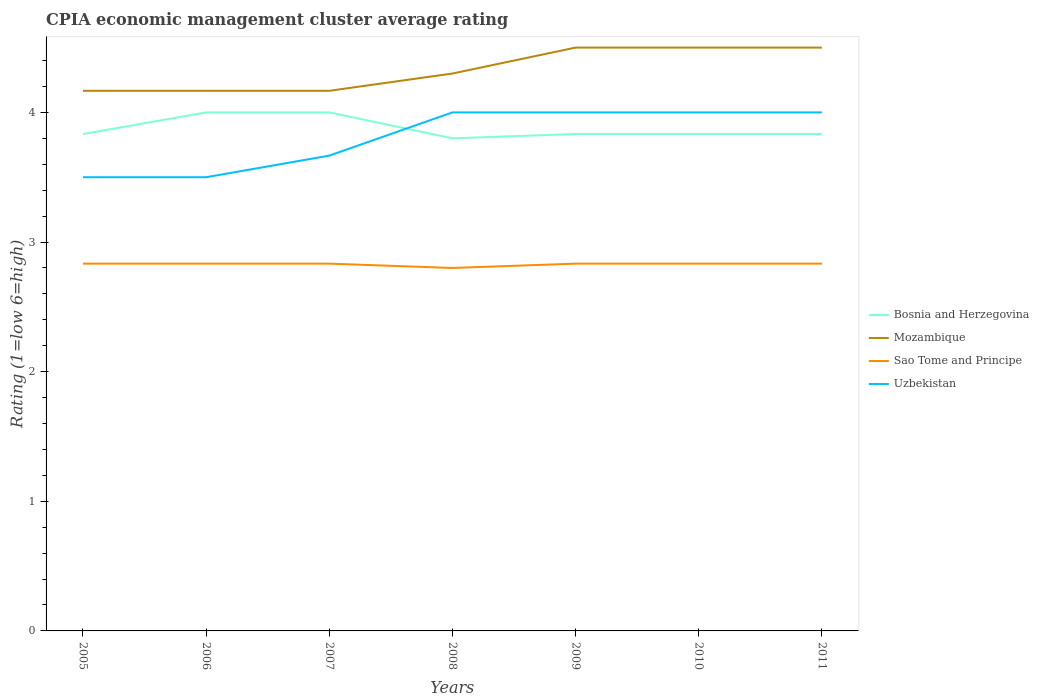How many different coloured lines are there?
Make the answer very short. 4. Is the number of lines equal to the number of legend labels?
Offer a terse response. Yes. In which year was the CPIA rating in Uzbekistan maximum?
Your answer should be compact. 2005. What is the total CPIA rating in Sao Tome and Principe in the graph?
Your answer should be very brief. 0.03. What is the difference between the highest and the second highest CPIA rating in Sao Tome and Principe?
Ensure brevity in your answer.  0.03. How many lines are there?
Ensure brevity in your answer.  4. Are the values on the major ticks of Y-axis written in scientific E-notation?
Give a very brief answer. No. Does the graph contain any zero values?
Your answer should be compact. No. Does the graph contain grids?
Keep it short and to the point. No. How many legend labels are there?
Provide a succinct answer. 4. How are the legend labels stacked?
Offer a very short reply. Vertical. What is the title of the graph?
Ensure brevity in your answer.  CPIA economic management cluster average rating. Does "Senegal" appear as one of the legend labels in the graph?
Provide a short and direct response. No. What is the label or title of the X-axis?
Ensure brevity in your answer.  Years. What is the label or title of the Y-axis?
Your response must be concise. Rating (1=low 6=high). What is the Rating (1=low 6=high) in Bosnia and Herzegovina in 2005?
Provide a succinct answer. 3.83. What is the Rating (1=low 6=high) in Mozambique in 2005?
Your answer should be very brief. 4.17. What is the Rating (1=low 6=high) of Sao Tome and Principe in 2005?
Give a very brief answer. 2.83. What is the Rating (1=low 6=high) in Mozambique in 2006?
Provide a succinct answer. 4.17. What is the Rating (1=low 6=high) in Sao Tome and Principe in 2006?
Make the answer very short. 2.83. What is the Rating (1=low 6=high) in Uzbekistan in 2006?
Your answer should be very brief. 3.5. What is the Rating (1=low 6=high) of Mozambique in 2007?
Keep it short and to the point. 4.17. What is the Rating (1=low 6=high) of Sao Tome and Principe in 2007?
Offer a very short reply. 2.83. What is the Rating (1=low 6=high) of Uzbekistan in 2007?
Keep it short and to the point. 3.67. What is the Rating (1=low 6=high) of Bosnia and Herzegovina in 2008?
Ensure brevity in your answer.  3.8. What is the Rating (1=low 6=high) in Bosnia and Herzegovina in 2009?
Your response must be concise. 3.83. What is the Rating (1=low 6=high) in Sao Tome and Principe in 2009?
Your answer should be very brief. 2.83. What is the Rating (1=low 6=high) in Bosnia and Herzegovina in 2010?
Provide a succinct answer. 3.83. What is the Rating (1=low 6=high) in Mozambique in 2010?
Offer a very short reply. 4.5. What is the Rating (1=low 6=high) of Sao Tome and Principe in 2010?
Your answer should be compact. 2.83. What is the Rating (1=low 6=high) of Uzbekistan in 2010?
Offer a very short reply. 4. What is the Rating (1=low 6=high) in Bosnia and Herzegovina in 2011?
Keep it short and to the point. 3.83. What is the Rating (1=low 6=high) in Sao Tome and Principe in 2011?
Your answer should be very brief. 2.83. What is the Rating (1=low 6=high) of Uzbekistan in 2011?
Your answer should be compact. 4. Across all years, what is the maximum Rating (1=low 6=high) in Sao Tome and Principe?
Give a very brief answer. 2.83. Across all years, what is the maximum Rating (1=low 6=high) in Uzbekistan?
Ensure brevity in your answer.  4. Across all years, what is the minimum Rating (1=low 6=high) in Mozambique?
Make the answer very short. 4.17. Across all years, what is the minimum Rating (1=low 6=high) of Sao Tome and Principe?
Provide a succinct answer. 2.8. What is the total Rating (1=low 6=high) in Bosnia and Herzegovina in the graph?
Your response must be concise. 27.13. What is the total Rating (1=low 6=high) in Mozambique in the graph?
Your response must be concise. 30.3. What is the total Rating (1=low 6=high) in Sao Tome and Principe in the graph?
Make the answer very short. 19.8. What is the total Rating (1=low 6=high) of Uzbekistan in the graph?
Keep it short and to the point. 26.67. What is the difference between the Rating (1=low 6=high) in Bosnia and Herzegovina in 2005 and that in 2006?
Your response must be concise. -0.17. What is the difference between the Rating (1=low 6=high) in Sao Tome and Principe in 2005 and that in 2006?
Your response must be concise. 0. What is the difference between the Rating (1=low 6=high) in Bosnia and Herzegovina in 2005 and that in 2007?
Provide a succinct answer. -0.17. What is the difference between the Rating (1=low 6=high) of Mozambique in 2005 and that in 2007?
Your answer should be compact. 0. What is the difference between the Rating (1=low 6=high) of Sao Tome and Principe in 2005 and that in 2007?
Provide a succinct answer. 0. What is the difference between the Rating (1=low 6=high) in Uzbekistan in 2005 and that in 2007?
Your response must be concise. -0.17. What is the difference between the Rating (1=low 6=high) of Bosnia and Herzegovina in 2005 and that in 2008?
Keep it short and to the point. 0.03. What is the difference between the Rating (1=low 6=high) in Mozambique in 2005 and that in 2008?
Keep it short and to the point. -0.13. What is the difference between the Rating (1=low 6=high) in Uzbekistan in 2005 and that in 2008?
Offer a terse response. -0.5. What is the difference between the Rating (1=low 6=high) in Sao Tome and Principe in 2005 and that in 2009?
Your response must be concise. 0. What is the difference between the Rating (1=low 6=high) of Sao Tome and Principe in 2005 and that in 2010?
Your answer should be compact. 0. What is the difference between the Rating (1=low 6=high) in Uzbekistan in 2005 and that in 2010?
Give a very brief answer. -0.5. What is the difference between the Rating (1=low 6=high) in Bosnia and Herzegovina in 2005 and that in 2011?
Ensure brevity in your answer.  0. What is the difference between the Rating (1=low 6=high) in Mozambique in 2005 and that in 2011?
Offer a terse response. -0.33. What is the difference between the Rating (1=low 6=high) in Uzbekistan in 2005 and that in 2011?
Give a very brief answer. -0.5. What is the difference between the Rating (1=low 6=high) in Bosnia and Herzegovina in 2006 and that in 2007?
Provide a short and direct response. 0. What is the difference between the Rating (1=low 6=high) of Sao Tome and Principe in 2006 and that in 2007?
Your response must be concise. 0. What is the difference between the Rating (1=low 6=high) of Bosnia and Herzegovina in 2006 and that in 2008?
Provide a succinct answer. 0.2. What is the difference between the Rating (1=low 6=high) in Mozambique in 2006 and that in 2008?
Ensure brevity in your answer.  -0.13. What is the difference between the Rating (1=low 6=high) in Sao Tome and Principe in 2006 and that in 2008?
Your response must be concise. 0.03. What is the difference between the Rating (1=low 6=high) in Sao Tome and Principe in 2006 and that in 2009?
Your answer should be compact. 0. What is the difference between the Rating (1=low 6=high) of Bosnia and Herzegovina in 2006 and that in 2010?
Keep it short and to the point. 0.17. What is the difference between the Rating (1=low 6=high) in Mozambique in 2006 and that in 2010?
Provide a succinct answer. -0.33. What is the difference between the Rating (1=low 6=high) in Sao Tome and Principe in 2006 and that in 2010?
Make the answer very short. 0. What is the difference between the Rating (1=low 6=high) in Bosnia and Herzegovina in 2006 and that in 2011?
Offer a terse response. 0.17. What is the difference between the Rating (1=low 6=high) of Mozambique in 2007 and that in 2008?
Your answer should be compact. -0.13. What is the difference between the Rating (1=low 6=high) of Sao Tome and Principe in 2007 and that in 2008?
Give a very brief answer. 0.03. What is the difference between the Rating (1=low 6=high) of Uzbekistan in 2007 and that in 2009?
Keep it short and to the point. -0.33. What is the difference between the Rating (1=low 6=high) in Bosnia and Herzegovina in 2007 and that in 2010?
Offer a very short reply. 0.17. What is the difference between the Rating (1=low 6=high) of Mozambique in 2007 and that in 2010?
Offer a terse response. -0.33. What is the difference between the Rating (1=low 6=high) in Sao Tome and Principe in 2007 and that in 2010?
Offer a very short reply. 0. What is the difference between the Rating (1=low 6=high) in Bosnia and Herzegovina in 2007 and that in 2011?
Your answer should be compact. 0.17. What is the difference between the Rating (1=low 6=high) in Sao Tome and Principe in 2007 and that in 2011?
Offer a very short reply. 0. What is the difference between the Rating (1=low 6=high) of Bosnia and Herzegovina in 2008 and that in 2009?
Offer a very short reply. -0.03. What is the difference between the Rating (1=low 6=high) in Mozambique in 2008 and that in 2009?
Offer a very short reply. -0.2. What is the difference between the Rating (1=low 6=high) in Sao Tome and Principe in 2008 and that in 2009?
Your answer should be very brief. -0.03. What is the difference between the Rating (1=low 6=high) in Bosnia and Herzegovina in 2008 and that in 2010?
Keep it short and to the point. -0.03. What is the difference between the Rating (1=low 6=high) in Sao Tome and Principe in 2008 and that in 2010?
Give a very brief answer. -0.03. What is the difference between the Rating (1=low 6=high) of Bosnia and Herzegovina in 2008 and that in 2011?
Ensure brevity in your answer.  -0.03. What is the difference between the Rating (1=low 6=high) in Mozambique in 2008 and that in 2011?
Your response must be concise. -0.2. What is the difference between the Rating (1=low 6=high) of Sao Tome and Principe in 2008 and that in 2011?
Keep it short and to the point. -0.03. What is the difference between the Rating (1=low 6=high) of Bosnia and Herzegovina in 2009 and that in 2011?
Your answer should be very brief. 0. What is the difference between the Rating (1=low 6=high) of Mozambique in 2009 and that in 2011?
Give a very brief answer. 0. What is the difference between the Rating (1=low 6=high) in Uzbekistan in 2009 and that in 2011?
Provide a succinct answer. 0. What is the difference between the Rating (1=low 6=high) in Mozambique in 2010 and that in 2011?
Provide a succinct answer. 0. What is the difference between the Rating (1=low 6=high) of Sao Tome and Principe in 2010 and that in 2011?
Offer a very short reply. 0. What is the difference between the Rating (1=low 6=high) in Uzbekistan in 2010 and that in 2011?
Provide a succinct answer. 0. What is the difference between the Rating (1=low 6=high) of Bosnia and Herzegovina in 2005 and the Rating (1=low 6=high) of Mozambique in 2006?
Provide a succinct answer. -0.33. What is the difference between the Rating (1=low 6=high) in Bosnia and Herzegovina in 2005 and the Rating (1=low 6=high) in Uzbekistan in 2006?
Offer a very short reply. 0.33. What is the difference between the Rating (1=low 6=high) in Mozambique in 2005 and the Rating (1=low 6=high) in Uzbekistan in 2006?
Your answer should be very brief. 0.67. What is the difference between the Rating (1=low 6=high) of Mozambique in 2005 and the Rating (1=low 6=high) of Uzbekistan in 2007?
Offer a very short reply. 0.5. What is the difference between the Rating (1=low 6=high) of Bosnia and Herzegovina in 2005 and the Rating (1=low 6=high) of Mozambique in 2008?
Provide a short and direct response. -0.47. What is the difference between the Rating (1=low 6=high) of Bosnia and Herzegovina in 2005 and the Rating (1=low 6=high) of Sao Tome and Principe in 2008?
Provide a succinct answer. 1.03. What is the difference between the Rating (1=low 6=high) in Mozambique in 2005 and the Rating (1=low 6=high) in Sao Tome and Principe in 2008?
Offer a terse response. 1.37. What is the difference between the Rating (1=low 6=high) in Sao Tome and Principe in 2005 and the Rating (1=low 6=high) in Uzbekistan in 2008?
Offer a terse response. -1.17. What is the difference between the Rating (1=low 6=high) in Mozambique in 2005 and the Rating (1=low 6=high) in Sao Tome and Principe in 2009?
Ensure brevity in your answer.  1.33. What is the difference between the Rating (1=low 6=high) of Sao Tome and Principe in 2005 and the Rating (1=low 6=high) of Uzbekistan in 2009?
Give a very brief answer. -1.17. What is the difference between the Rating (1=low 6=high) in Bosnia and Herzegovina in 2005 and the Rating (1=low 6=high) in Sao Tome and Principe in 2010?
Give a very brief answer. 1. What is the difference between the Rating (1=low 6=high) of Sao Tome and Principe in 2005 and the Rating (1=low 6=high) of Uzbekistan in 2010?
Offer a very short reply. -1.17. What is the difference between the Rating (1=low 6=high) in Bosnia and Herzegovina in 2005 and the Rating (1=low 6=high) in Mozambique in 2011?
Your answer should be compact. -0.67. What is the difference between the Rating (1=low 6=high) in Bosnia and Herzegovina in 2005 and the Rating (1=low 6=high) in Sao Tome and Principe in 2011?
Your response must be concise. 1. What is the difference between the Rating (1=low 6=high) in Mozambique in 2005 and the Rating (1=low 6=high) in Uzbekistan in 2011?
Ensure brevity in your answer.  0.17. What is the difference between the Rating (1=low 6=high) in Sao Tome and Principe in 2005 and the Rating (1=low 6=high) in Uzbekistan in 2011?
Provide a succinct answer. -1.17. What is the difference between the Rating (1=low 6=high) of Bosnia and Herzegovina in 2006 and the Rating (1=low 6=high) of Sao Tome and Principe in 2007?
Your answer should be very brief. 1.17. What is the difference between the Rating (1=low 6=high) in Bosnia and Herzegovina in 2006 and the Rating (1=low 6=high) in Uzbekistan in 2007?
Provide a short and direct response. 0.33. What is the difference between the Rating (1=low 6=high) of Mozambique in 2006 and the Rating (1=low 6=high) of Sao Tome and Principe in 2007?
Offer a terse response. 1.33. What is the difference between the Rating (1=low 6=high) of Mozambique in 2006 and the Rating (1=low 6=high) of Uzbekistan in 2007?
Your response must be concise. 0.5. What is the difference between the Rating (1=low 6=high) in Sao Tome and Principe in 2006 and the Rating (1=low 6=high) in Uzbekistan in 2007?
Make the answer very short. -0.83. What is the difference between the Rating (1=low 6=high) of Bosnia and Herzegovina in 2006 and the Rating (1=low 6=high) of Mozambique in 2008?
Offer a very short reply. -0.3. What is the difference between the Rating (1=low 6=high) of Mozambique in 2006 and the Rating (1=low 6=high) of Sao Tome and Principe in 2008?
Offer a very short reply. 1.37. What is the difference between the Rating (1=low 6=high) in Mozambique in 2006 and the Rating (1=low 6=high) in Uzbekistan in 2008?
Make the answer very short. 0.17. What is the difference between the Rating (1=low 6=high) in Sao Tome and Principe in 2006 and the Rating (1=low 6=high) in Uzbekistan in 2008?
Give a very brief answer. -1.17. What is the difference between the Rating (1=low 6=high) of Bosnia and Herzegovina in 2006 and the Rating (1=low 6=high) of Sao Tome and Principe in 2009?
Your answer should be compact. 1.17. What is the difference between the Rating (1=low 6=high) in Mozambique in 2006 and the Rating (1=low 6=high) in Sao Tome and Principe in 2009?
Keep it short and to the point. 1.33. What is the difference between the Rating (1=low 6=high) of Sao Tome and Principe in 2006 and the Rating (1=low 6=high) of Uzbekistan in 2009?
Your answer should be compact. -1.17. What is the difference between the Rating (1=low 6=high) of Bosnia and Herzegovina in 2006 and the Rating (1=low 6=high) of Sao Tome and Principe in 2010?
Provide a succinct answer. 1.17. What is the difference between the Rating (1=low 6=high) of Mozambique in 2006 and the Rating (1=low 6=high) of Sao Tome and Principe in 2010?
Offer a very short reply. 1.33. What is the difference between the Rating (1=low 6=high) in Sao Tome and Principe in 2006 and the Rating (1=low 6=high) in Uzbekistan in 2010?
Give a very brief answer. -1.17. What is the difference between the Rating (1=low 6=high) in Bosnia and Herzegovina in 2006 and the Rating (1=low 6=high) in Sao Tome and Principe in 2011?
Offer a very short reply. 1.17. What is the difference between the Rating (1=low 6=high) in Sao Tome and Principe in 2006 and the Rating (1=low 6=high) in Uzbekistan in 2011?
Provide a short and direct response. -1.17. What is the difference between the Rating (1=low 6=high) in Bosnia and Herzegovina in 2007 and the Rating (1=low 6=high) in Mozambique in 2008?
Keep it short and to the point. -0.3. What is the difference between the Rating (1=low 6=high) in Mozambique in 2007 and the Rating (1=low 6=high) in Sao Tome and Principe in 2008?
Provide a succinct answer. 1.37. What is the difference between the Rating (1=low 6=high) of Sao Tome and Principe in 2007 and the Rating (1=low 6=high) of Uzbekistan in 2008?
Your answer should be very brief. -1.17. What is the difference between the Rating (1=low 6=high) in Mozambique in 2007 and the Rating (1=low 6=high) in Sao Tome and Principe in 2009?
Offer a very short reply. 1.33. What is the difference between the Rating (1=low 6=high) in Mozambique in 2007 and the Rating (1=low 6=high) in Uzbekistan in 2009?
Provide a succinct answer. 0.17. What is the difference between the Rating (1=low 6=high) in Sao Tome and Principe in 2007 and the Rating (1=low 6=high) in Uzbekistan in 2009?
Your answer should be compact. -1.17. What is the difference between the Rating (1=low 6=high) of Bosnia and Herzegovina in 2007 and the Rating (1=low 6=high) of Uzbekistan in 2010?
Keep it short and to the point. 0. What is the difference between the Rating (1=low 6=high) of Sao Tome and Principe in 2007 and the Rating (1=low 6=high) of Uzbekistan in 2010?
Make the answer very short. -1.17. What is the difference between the Rating (1=low 6=high) of Bosnia and Herzegovina in 2007 and the Rating (1=low 6=high) of Uzbekistan in 2011?
Keep it short and to the point. 0. What is the difference between the Rating (1=low 6=high) in Mozambique in 2007 and the Rating (1=low 6=high) in Sao Tome and Principe in 2011?
Keep it short and to the point. 1.33. What is the difference between the Rating (1=low 6=high) in Mozambique in 2007 and the Rating (1=low 6=high) in Uzbekistan in 2011?
Your response must be concise. 0.17. What is the difference between the Rating (1=low 6=high) of Sao Tome and Principe in 2007 and the Rating (1=low 6=high) of Uzbekistan in 2011?
Make the answer very short. -1.17. What is the difference between the Rating (1=low 6=high) in Bosnia and Herzegovina in 2008 and the Rating (1=low 6=high) in Mozambique in 2009?
Make the answer very short. -0.7. What is the difference between the Rating (1=low 6=high) of Bosnia and Herzegovina in 2008 and the Rating (1=low 6=high) of Sao Tome and Principe in 2009?
Your answer should be compact. 0.97. What is the difference between the Rating (1=low 6=high) in Mozambique in 2008 and the Rating (1=low 6=high) in Sao Tome and Principe in 2009?
Your answer should be very brief. 1.47. What is the difference between the Rating (1=low 6=high) of Sao Tome and Principe in 2008 and the Rating (1=low 6=high) of Uzbekistan in 2009?
Make the answer very short. -1.2. What is the difference between the Rating (1=low 6=high) in Bosnia and Herzegovina in 2008 and the Rating (1=low 6=high) in Mozambique in 2010?
Your answer should be very brief. -0.7. What is the difference between the Rating (1=low 6=high) of Bosnia and Herzegovina in 2008 and the Rating (1=low 6=high) of Sao Tome and Principe in 2010?
Make the answer very short. 0.97. What is the difference between the Rating (1=low 6=high) in Bosnia and Herzegovina in 2008 and the Rating (1=low 6=high) in Uzbekistan in 2010?
Ensure brevity in your answer.  -0.2. What is the difference between the Rating (1=low 6=high) of Mozambique in 2008 and the Rating (1=low 6=high) of Sao Tome and Principe in 2010?
Offer a very short reply. 1.47. What is the difference between the Rating (1=low 6=high) in Sao Tome and Principe in 2008 and the Rating (1=low 6=high) in Uzbekistan in 2010?
Your answer should be very brief. -1.2. What is the difference between the Rating (1=low 6=high) in Bosnia and Herzegovina in 2008 and the Rating (1=low 6=high) in Mozambique in 2011?
Make the answer very short. -0.7. What is the difference between the Rating (1=low 6=high) of Bosnia and Herzegovina in 2008 and the Rating (1=low 6=high) of Sao Tome and Principe in 2011?
Provide a short and direct response. 0.97. What is the difference between the Rating (1=low 6=high) in Bosnia and Herzegovina in 2008 and the Rating (1=low 6=high) in Uzbekistan in 2011?
Offer a terse response. -0.2. What is the difference between the Rating (1=low 6=high) of Mozambique in 2008 and the Rating (1=low 6=high) of Sao Tome and Principe in 2011?
Give a very brief answer. 1.47. What is the difference between the Rating (1=low 6=high) of Mozambique in 2008 and the Rating (1=low 6=high) of Uzbekistan in 2011?
Ensure brevity in your answer.  0.3. What is the difference between the Rating (1=low 6=high) of Bosnia and Herzegovina in 2009 and the Rating (1=low 6=high) of Mozambique in 2010?
Your response must be concise. -0.67. What is the difference between the Rating (1=low 6=high) of Bosnia and Herzegovina in 2009 and the Rating (1=low 6=high) of Uzbekistan in 2010?
Offer a terse response. -0.17. What is the difference between the Rating (1=low 6=high) in Mozambique in 2009 and the Rating (1=low 6=high) in Uzbekistan in 2010?
Give a very brief answer. 0.5. What is the difference between the Rating (1=low 6=high) in Sao Tome and Principe in 2009 and the Rating (1=low 6=high) in Uzbekistan in 2010?
Keep it short and to the point. -1.17. What is the difference between the Rating (1=low 6=high) in Bosnia and Herzegovina in 2009 and the Rating (1=low 6=high) in Mozambique in 2011?
Offer a very short reply. -0.67. What is the difference between the Rating (1=low 6=high) of Bosnia and Herzegovina in 2009 and the Rating (1=low 6=high) of Sao Tome and Principe in 2011?
Your answer should be very brief. 1. What is the difference between the Rating (1=low 6=high) in Mozambique in 2009 and the Rating (1=low 6=high) in Uzbekistan in 2011?
Offer a terse response. 0.5. What is the difference between the Rating (1=low 6=high) of Sao Tome and Principe in 2009 and the Rating (1=low 6=high) of Uzbekistan in 2011?
Keep it short and to the point. -1.17. What is the difference between the Rating (1=low 6=high) of Mozambique in 2010 and the Rating (1=low 6=high) of Uzbekistan in 2011?
Your answer should be very brief. 0.5. What is the difference between the Rating (1=low 6=high) of Sao Tome and Principe in 2010 and the Rating (1=low 6=high) of Uzbekistan in 2011?
Provide a short and direct response. -1.17. What is the average Rating (1=low 6=high) of Bosnia and Herzegovina per year?
Offer a very short reply. 3.88. What is the average Rating (1=low 6=high) of Mozambique per year?
Provide a short and direct response. 4.33. What is the average Rating (1=low 6=high) of Sao Tome and Principe per year?
Make the answer very short. 2.83. What is the average Rating (1=low 6=high) in Uzbekistan per year?
Keep it short and to the point. 3.81. In the year 2005, what is the difference between the Rating (1=low 6=high) of Bosnia and Herzegovina and Rating (1=low 6=high) of Sao Tome and Principe?
Your answer should be compact. 1. In the year 2005, what is the difference between the Rating (1=low 6=high) of Bosnia and Herzegovina and Rating (1=low 6=high) of Uzbekistan?
Offer a very short reply. 0.33. In the year 2005, what is the difference between the Rating (1=low 6=high) of Mozambique and Rating (1=low 6=high) of Uzbekistan?
Offer a very short reply. 0.67. In the year 2006, what is the difference between the Rating (1=low 6=high) in Bosnia and Herzegovina and Rating (1=low 6=high) in Mozambique?
Your answer should be compact. -0.17. In the year 2006, what is the difference between the Rating (1=low 6=high) in Bosnia and Herzegovina and Rating (1=low 6=high) in Uzbekistan?
Ensure brevity in your answer.  0.5. In the year 2006, what is the difference between the Rating (1=low 6=high) of Mozambique and Rating (1=low 6=high) of Uzbekistan?
Ensure brevity in your answer.  0.67. In the year 2006, what is the difference between the Rating (1=low 6=high) of Sao Tome and Principe and Rating (1=low 6=high) of Uzbekistan?
Your answer should be very brief. -0.67. In the year 2007, what is the difference between the Rating (1=low 6=high) in Bosnia and Herzegovina and Rating (1=low 6=high) in Mozambique?
Provide a short and direct response. -0.17. In the year 2007, what is the difference between the Rating (1=low 6=high) of Bosnia and Herzegovina and Rating (1=low 6=high) of Uzbekistan?
Provide a succinct answer. 0.33. In the year 2007, what is the difference between the Rating (1=low 6=high) of Mozambique and Rating (1=low 6=high) of Sao Tome and Principe?
Offer a very short reply. 1.33. In the year 2008, what is the difference between the Rating (1=low 6=high) in Bosnia and Herzegovina and Rating (1=low 6=high) in Mozambique?
Offer a very short reply. -0.5. In the year 2008, what is the difference between the Rating (1=low 6=high) of Bosnia and Herzegovina and Rating (1=low 6=high) of Uzbekistan?
Give a very brief answer. -0.2. In the year 2009, what is the difference between the Rating (1=low 6=high) in Bosnia and Herzegovina and Rating (1=low 6=high) in Mozambique?
Offer a very short reply. -0.67. In the year 2009, what is the difference between the Rating (1=low 6=high) in Bosnia and Herzegovina and Rating (1=low 6=high) in Sao Tome and Principe?
Your answer should be very brief. 1. In the year 2009, what is the difference between the Rating (1=low 6=high) of Bosnia and Herzegovina and Rating (1=low 6=high) of Uzbekistan?
Provide a succinct answer. -0.17. In the year 2009, what is the difference between the Rating (1=low 6=high) in Mozambique and Rating (1=low 6=high) in Uzbekistan?
Keep it short and to the point. 0.5. In the year 2009, what is the difference between the Rating (1=low 6=high) in Sao Tome and Principe and Rating (1=low 6=high) in Uzbekistan?
Your response must be concise. -1.17. In the year 2010, what is the difference between the Rating (1=low 6=high) of Bosnia and Herzegovina and Rating (1=low 6=high) of Mozambique?
Your answer should be compact. -0.67. In the year 2010, what is the difference between the Rating (1=low 6=high) in Mozambique and Rating (1=low 6=high) in Sao Tome and Principe?
Your answer should be very brief. 1.67. In the year 2010, what is the difference between the Rating (1=low 6=high) in Mozambique and Rating (1=low 6=high) in Uzbekistan?
Ensure brevity in your answer.  0.5. In the year 2010, what is the difference between the Rating (1=low 6=high) in Sao Tome and Principe and Rating (1=low 6=high) in Uzbekistan?
Make the answer very short. -1.17. In the year 2011, what is the difference between the Rating (1=low 6=high) of Bosnia and Herzegovina and Rating (1=low 6=high) of Mozambique?
Your answer should be compact. -0.67. In the year 2011, what is the difference between the Rating (1=low 6=high) in Bosnia and Herzegovina and Rating (1=low 6=high) in Sao Tome and Principe?
Offer a very short reply. 1. In the year 2011, what is the difference between the Rating (1=low 6=high) in Sao Tome and Principe and Rating (1=low 6=high) in Uzbekistan?
Make the answer very short. -1.17. What is the ratio of the Rating (1=low 6=high) of Bosnia and Herzegovina in 2005 to that in 2006?
Provide a succinct answer. 0.96. What is the ratio of the Rating (1=low 6=high) in Mozambique in 2005 to that in 2006?
Make the answer very short. 1. What is the ratio of the Rating (1=low 6=high) in Sao Tome and Principe in 2005 to that in 2006?
Offer a very short reply. 1. What is the ratio of the Rating (1=low 6=high) in Uzbekistan in 2005 to that in 2006?
Ensure brevity in your answer.  1. What is the ratio of the Rating (1=low 6=high) of Mozambique in 2005 to that in 2007?
Provide a succinct answer. 1. What is the ratio of the Rating (1=low 6=high) of Uzbekistan in 2005 to that in 2007?
Give a very brief answer. 0.95. What is the ratio of the Rating (1=low 6=high) of Bosnia and Herzegovina in 2005 to that in 2008?
Provide a short and direct response. 1.01. What is the ratio of the Rating (1=low 6=high) of Mozambique in 2005 to that in 2008?
Keep it short and to the point. 0.97. What is the ratio of the Rating (1=low 6=high) in Sao Tome and Principe in 2005 to that in 2008?
Make the answer very short. 1.01. What is the ratio of the Rating (1=low 6=high) of Bosnia and Herzegovina in 2005 to that in 2009?
Keep it short and to the point. 1. What is the ratio of the Rating (1=low 6=high) of Mozambique in 2005 to that in 2009?
Keep it short and to the point. 0.93. What is the ratio of the Rating (1=low 6=high) in Bosnia and Herzegovina in 2005 to that in 2010?
Make the answer very short. 1. What is the ratio of the Rating (1=low 6=high) in Mozambique in 2005 to that in 2010?
Provide a succinct answer. 0.93. What is the ratio of the Rating (1=low 6=high) of Sao Tome and Principe in 2005 to that in 2010?
Your response must be concise. 1. What is the ratio of the Rating (1=low 6=high) in Mozambique in 2005 to that in 2011?
Provide a succinct answer. 0.93. What is the ratio of the Rating (1=low 6=high) in Sao Tome and Principe in 2005 to that in 2011?
Provide a short and direct response. 1. What is the ratio of the Rating (1=low 6=high) of Uzbekistan in 2005 to that in 2011?
Make the answer very short. 0.88. What is the ratio of the Rating (1=low 6=high) of Bosnia and Herzegovina in 2006 to that in 2007?
Provide a short and direct response. 1. What is the ratio of the Rating (1=low 6=high) in Mozambique in 2006 to that in 2007?
Keep it short and to the point. 1. What is the ratio of the Rating (1=low 6=high) of Sao Tome and Principe in 2006 to that in 2007?
Provide a succinct answer. 1. What is the ratio of the Rating (1=low 6=high) of Uzbekistan in 2006 to that in 2007?
Provide a short and direct response. 0.95. What is the ratio of the Rating (1=low 6=high) of Bosnia and Herzegovina in 2006 to that in 2008?
Make the answer very short. 1.05. What is the ratio of the Rating (1=low 6=high) in Mozambique in 2006 to that in 2008?
Your answer should be very brief. 0.97. What is the ratio of the Rating (1=low 6=high) of Sao Tome and Principe in 2006 to that in 2008?
Give a very brief answer. 1.01. What is the ratio of the Rating (1=low 6=high) of Uzbekistan in 2006 to that in 2008?
Provide a short and direct response. 0.88. What is the ratio of the Rating (1=low 6=high) of Bosnia and Herzegovina in 2006 to that in 2009?
Offer a very short reply. 1.04. What is the ratio of the Rating (1=low 6=high) of Mozambique in 2006 to that in 2009?
Offer a terse response. 0.93. What is the ratio of the Rating (1=low 6=high) of Sao Tome and Principe in 2006 to that in 2009?
Your answer should be very brief. 1. What is the ratio of the Rating (1=low 6=high) of Uzbekistan in 2006 to that in 2009?
Offer a very short reply. 0.88. What is the ratio of the Rating (1=low 6=high) in Bosnia and Herzegovina in 2006 to that in 2010?
Your answer should be compact. 1.04. What is the ratio of the Rating (1=low 6=high) of Mozambique in 2006 to that in 2010?
Keep it short and to the point. 0.93. What is the ratio of the Rating (1=low 6=high) in Uzbekistan in 2006 to that in 2010?
Your answer should be compact. 0.88. What is the ratio of the Rating (1=low 6=high) of Bosnia and Herzegovina in 2006 to that in 2011?
Give a very brief answer. 1.04. What is the ratio of the Rating (1=low 6=high) of Mozambique in 2006 to that in 2011?
Give a very brief answer. 0.93. What is the ratio of the Rating (1=low 6=high) of Bosnia and Herzegovina in 2007 to that in 2008?
Your answer should be very brief. 1.05. What is the ratio of the Rating (1=low 6=high) in Mozambique in 2007 to that in 2008?
Ensure brevity in your answer.  0.97. What is the ratio of the Rating (1=low 6=high) in Sao Tome and Principe in 2007 to that in 2008?
Ensure brevity in your answer.  1.01. What is the ratio of the Rating (1=low 6=high) in Uzbekistan in 2007 to that in 2008?
Provide a succinct answer. 0.92. What is the ratio of the Rating (1=low 6=high) in Bosnia and Herzegovina in 2007 to that in 2009?
Give a very brief answer. 1.04. What is the ratio of the Rating (1=low 6=high) of Mozambique in 2007 to that in 2009?
Your answer should be compact. 0.93. What is the ratio of the Rating (1=low 6=high) of Sao Tome and Principe in 2007 to that in 2009?
Offer a terse response. 1. What is the ratio of the Rating (1=low 6=high) in Uzbekistan in 2007 to that in 2009?
Provide a short and direct response. 0.92. What is the ratio of the Rating (1=low 6=high) of Bosnia and Herzegovina in 2007 to that in 2010?
Ensure brevity in your answer.  1.04. What is the ratio of the Rating (1=low 6=high) of Mozambique in 2007 to that in 2010?
Offer a very short reply. 0.93. What is the ratio of the Rating (1=low 6=high) in Bosnia and Herzegovina in 2007 to that in 2011?
Provide a succinct answer. 1.04. What is the ratio of the Rating (1=low 6=high) in Mozambique in 2007 to that in 2011?
Your answer should be very brief. 0.93. What is the ratio of the Rating (1=low 6=high) in Sao Tome and Principe in 2007 to that in 2011?
Provide a succinct answer. 1. What is the ratio of the Rating (1=low 6=high) in Uzbekistan in 2007 to that in 2011?
Give a very brief answer. 0.92. What is the ratio of the Rating (1=low 6=high) of Mozambique in 2008 to that in 2009?
Your answer should be very brief. 0.96. What is the ratio of the Rating (1=low 6=high) of Sao Tome and Principe in 2008 to that in 2009?
Your answer should be very brief. 0.99. What is the ratio of the Rating (1=low 6=high) in Uzbekistan in 2008 to that in 2009?
Your response must be concise. 1. What is the ratio of the Rating (1=low 6=high) in Mozambique in 2008 to that in 2010?
Make the answer very short. 0.96. What is the ratio of the Rating (1=low 6=high) in Sao Tome and Principe in 2008 to that in 2010?
Make the answer very short. 0.99. What is the ratio of the Rating (1=low 6=high) in Uzbekistan in 2008 to that in 2010?
Provide a succinct answer. 1. What is the ratio of the Rating (1=low 6=high) in Mozambique in 2008 to that in 2011?
Give a very brief answer. 0.96. What is the ratio of the Rating (1=low 6=high) of Sao Tome and Principe in 2008 to that in 2011?
Your answer should be very brief. 0.99. What is the ratio of the Rating (1=low 6=high) of Uzbekistan in 2008 to that in 2011?
Give a very brief answer. 1. What is the ratio of the Rating (1=low 6=high) of Sao Tome and Principe in 2009 to that in 2010?
Give a very brief answer. 1. What is the ratio of the Rating (1=low 6=high) in Uzbekistan in 2009 to that in 2010?
Make the answer very short. 1. What is the ratio of the Rating (1=low 6=high) of Bosnia and Herzegovina in 2009 to that in 2011?
Your response must be concise. 1. What is the ratio of the Rating (1=low 6=high) of Uzbekistan in 2009 to that in 2011?
Offer a very short reply. 1. What is the ratio of the Rating (1=low 6=high) in Bosnia and Herzegovina in 2010 to that in 2011?
Keep it short and to the point. 1. What is the difference between the highest and the second highest Rating (1=low 6=high) in Mozambique?
Offer a terse response. 0. What is the difference between the highest and the second highest Rating (1=low 6=high) of Sao Tome and Principe?
Provide a succinct answer. 0. What is the difference between the highest and the second highest Rating (1=low 6=high) in Uzbekistan?
Ensure brevity in your answer.  0. What is the difference between the highest and the lowest Rating (1=low 6=high) in Bosnia and Herzegovina?
Keep it short and to the point. 0.2. What is the difference between the highest and the lowest Rating (1=low 6=high) in Mozambique?
Provide a succinct answer. 0.33. 